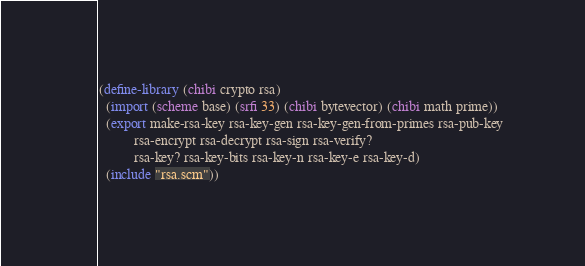<code> <loc_0><loc_0><loc_500><loc_500><_Scheme_>
(define-library (chibi crypto rsa)
  (import (scheme base) (srfi 33) (chibi bytevector) (chibi math prime))
  (export make-rsa-key rsa-key-gen rsa-key-gen-from-primes rsa-pub-key
          rsa-encrypt rsa-decrypt rsa-sign rsa-verify?
          rsa-key? rsa-key-bits rsa-key-n rsa-key-e rsa-key-d)
  (include "rsa.scm"))
</code> 